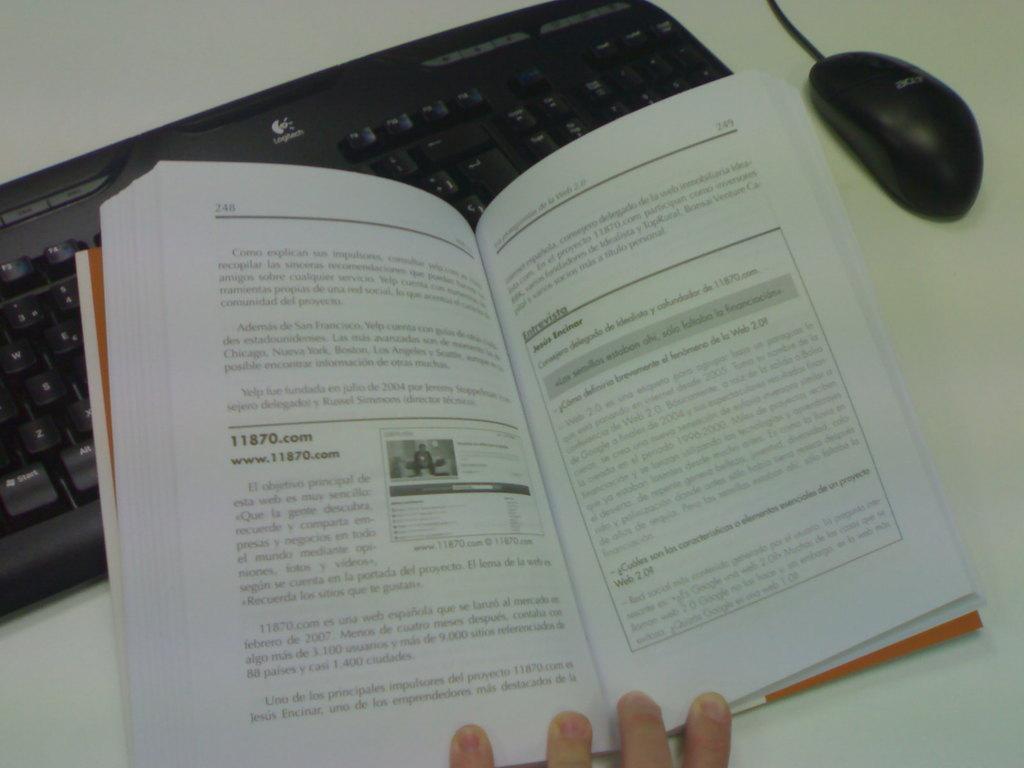What is the page number?
Your answer should be very brief. 248. 